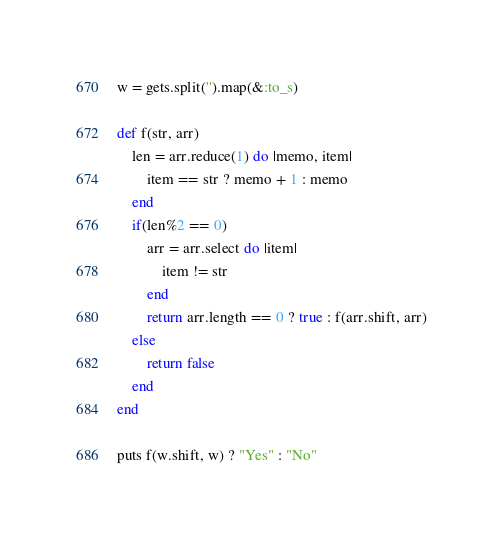<code> <loc_0><loc_0><loc_500><loc_500><_Ruby_>w = gets.split('').map(&:to_s)

def f(str, arr)
    len = arr.reduce(1) do |memo, item|
        item == str ? memo + 1 : memo
    end
    if(len%2 == 0) 
        arr = arr.select do |item|
            item != str
        end
        return arr.length == 0 ? true : f(arr.shift, arr)
    else 
        return false
    end
end

puts f(w.shift, w) ? "Yes" : "No"</code> 